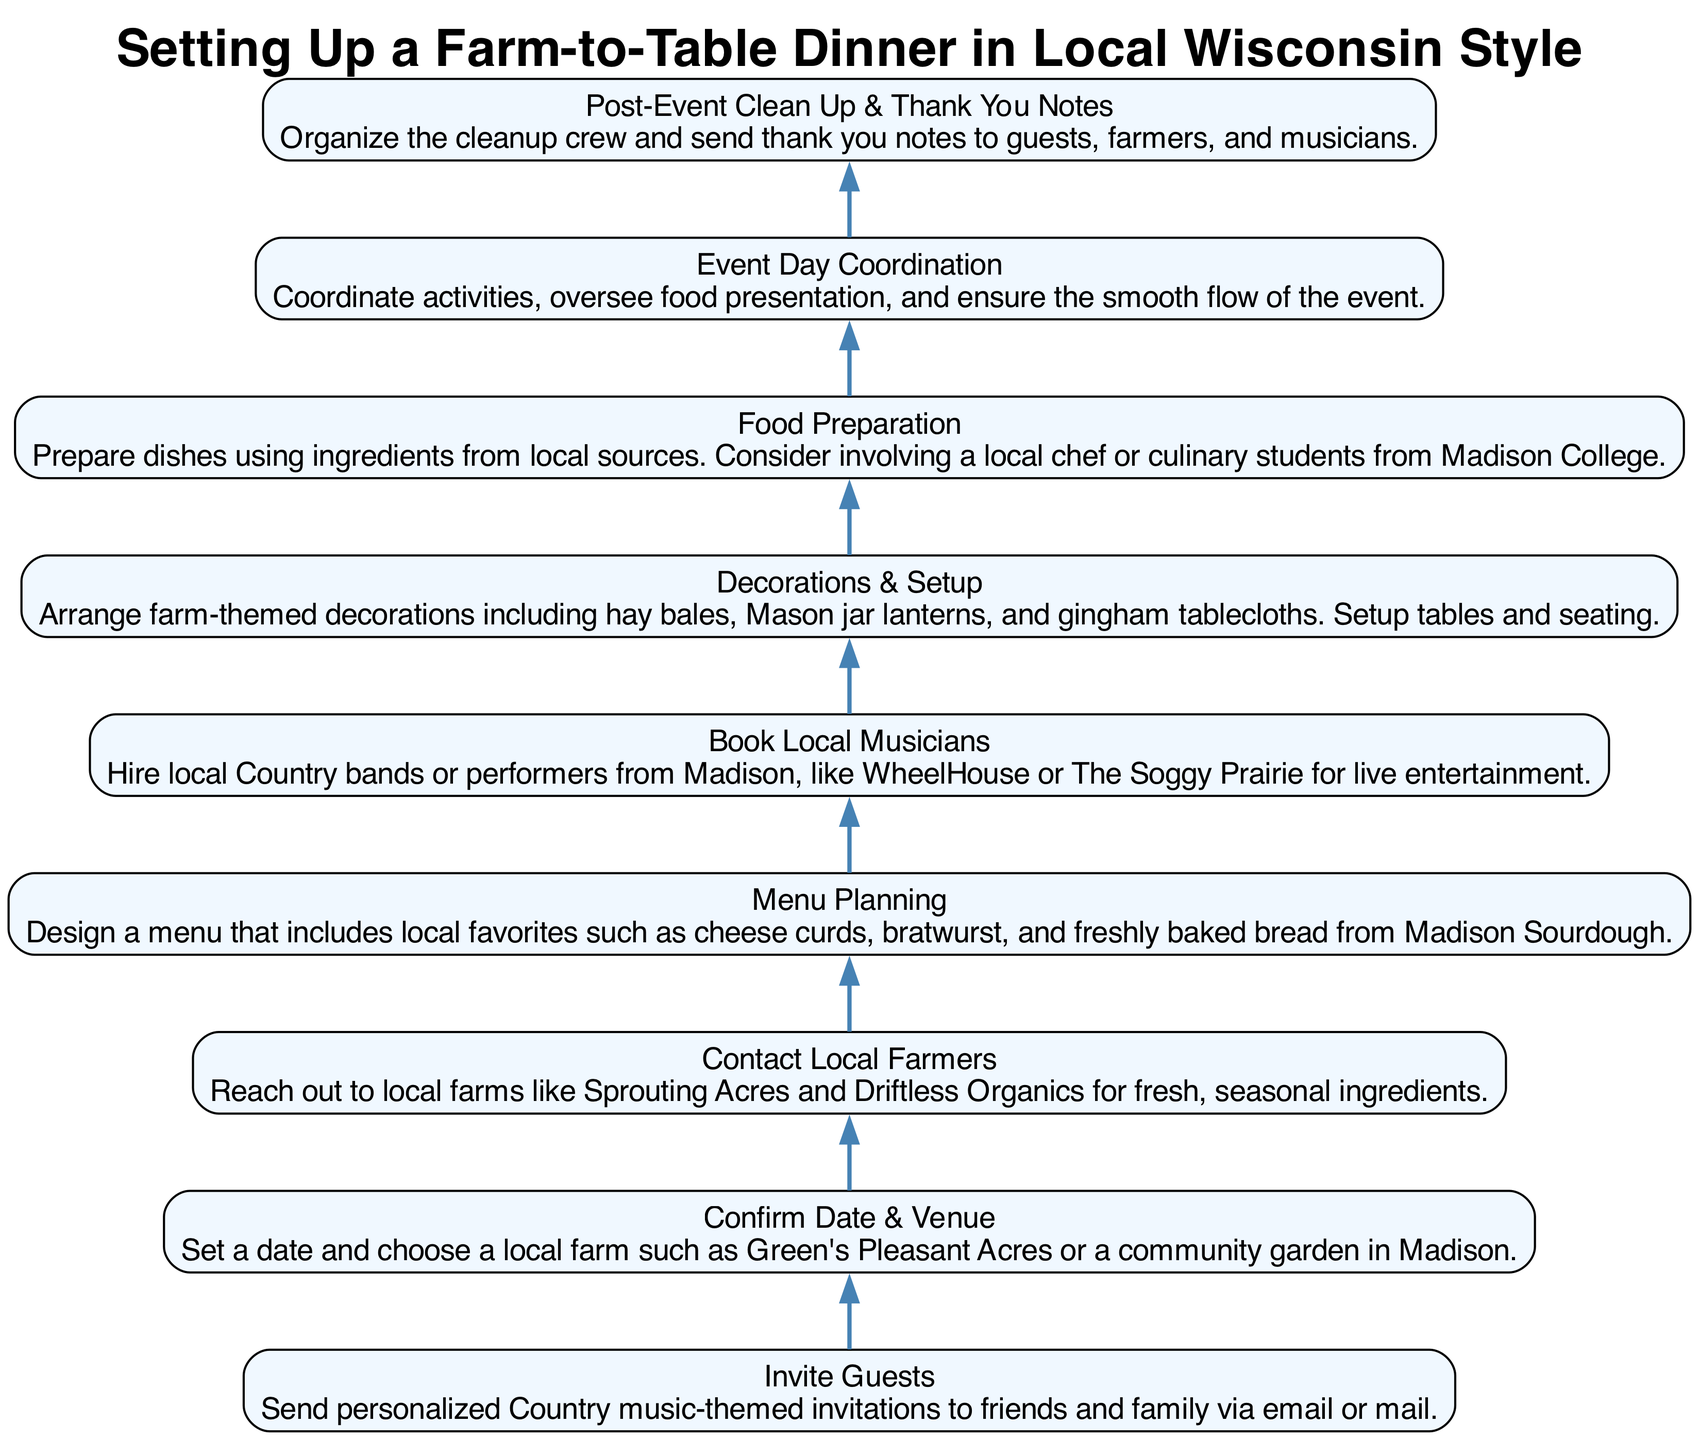What is the first step in the flow chart? The first step is "Invite Guests," which is clearly positioned at the bottom of the flow chart. This node is where the process begins, as it flows upward to the next steps in the instruction.
Answer: Invite Guests How many steps are in this diagram? By counting the nodes listed in the diagram, there are a total of eight distinct steps which outline the process from start to finish.
Answer: Eight Which step directly follows "Menu Planning"? The flow chart indicates that "Book Local Musicians" comes immediately after "Menu Planning," showing the succession of tasks in the context of setting up the dinner.
Answer: Book Local Musicians What type of entertainment is suggested in the flow chart? The instruction points to hiring "local Country bands or performers," specifically indicating a musical theme that aligns with the overall country vibe of the dinner.
Answer: Local Country bands What is one type of decoration recommended in the diagram? The node related to "Decorations & Setup" mentions "Mason jar lanterns" as one of the decorative elements to create the desired atmosphere, reflecting the farm-to-table theme.
Answer: Mason jar lanterns Which tasks are included in the "Post-Event Clean Up & Thank You Notes" step? This step includes organizing the cleanup crew and sending thank you notes, which are both after-event activities aimed at tidying up and showing appreciation.
Answer: Organize cleanup crew and send thank you notes To whom do you send thank you notes after the event? According to the diagram, thank you notes should be sent to "guests, farmers, and musicians," highlighting the participants involved in the event.
Answer: Guests, farmers, and musicians What is the final task in the flow chart? The last node in this flow chart is "Post-Event Clean Up & Thank You Notes," which indicates that this task is last and completes the flow of instructions for hosting the dinner.
Answer: Post-Event Clean Up & Thank You Notes 